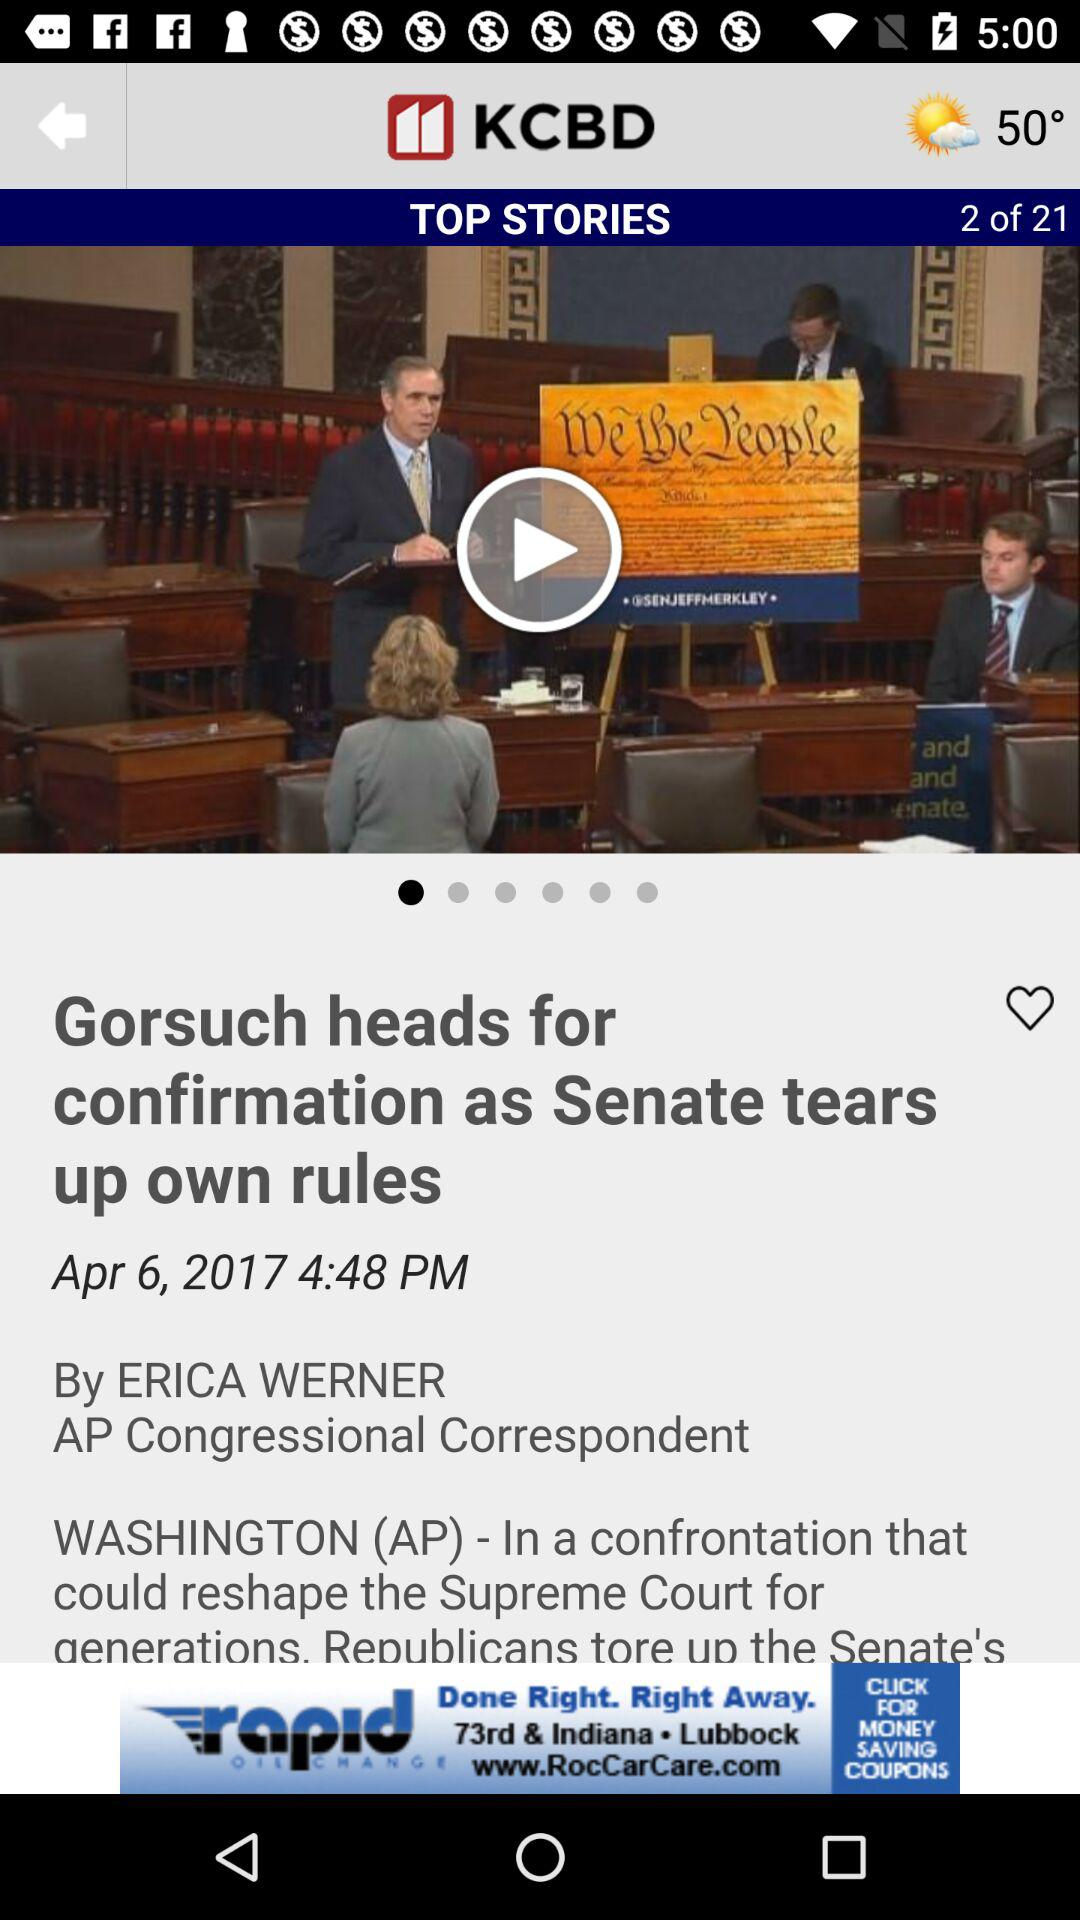What is the temperature? The temperature is 50°. 